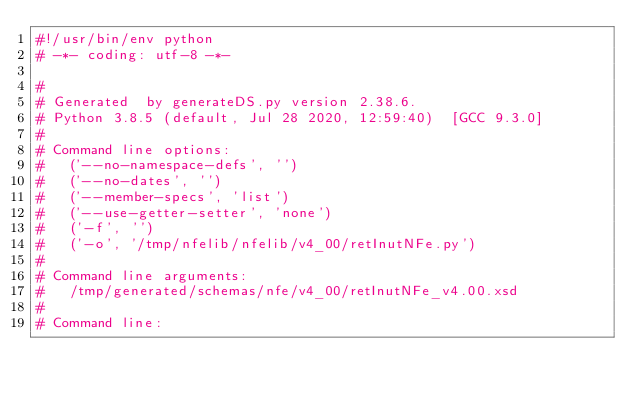Convert code to text. <code><loc_0><loc_0><loc_500><loc_500><_Python_>#!/usr/bin/env python
# -*- coding: utf-8 -*-

#
# Generated  by generateDS.py version 2.38.6.
# Python 3.8.5 (default, Jul 28 2020, 12:59:40)  [GCC 9.3.0]
#
# Command line options:
#   ('--no-namespace-defs', '')
#   ('--no-dates', '')
#   ('--member-specs', 'list')
#   ('--use-getter-setter', 'none')
#   ('-f', '')
#   ('-o', '/tmp/nfelib/nfelib/v4_00/retInutNFe.py')
#
# Command line arguments:
#   /tmp/generated/schemas/nfe/v4_00/retInutNFe_v4.00.xsd
#
# Command line:</code> 